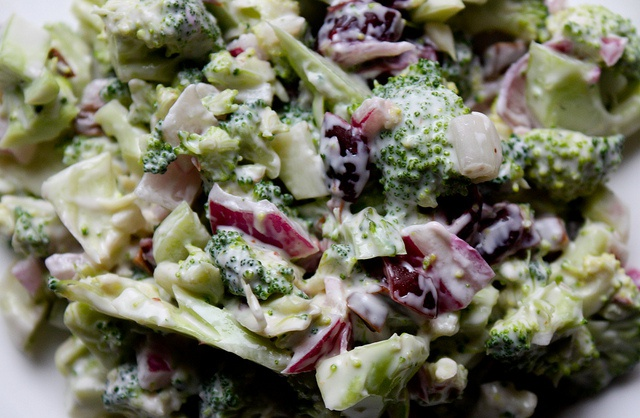Describe the objects in this image and their specific colors. I can see broccoli in lightgray, black, darkgray, and olive tones, broccoli in lightgray, darkgray, black, and gray tones, broccoli in lightgray, darkgray, olive, beige, and darkgreen tones, broccoli in lightgray, black, gray, darkgray, and darkgreen tones, and broccoli in lightgray, black, darkgray, darkgreen, and olive tones in this image. 